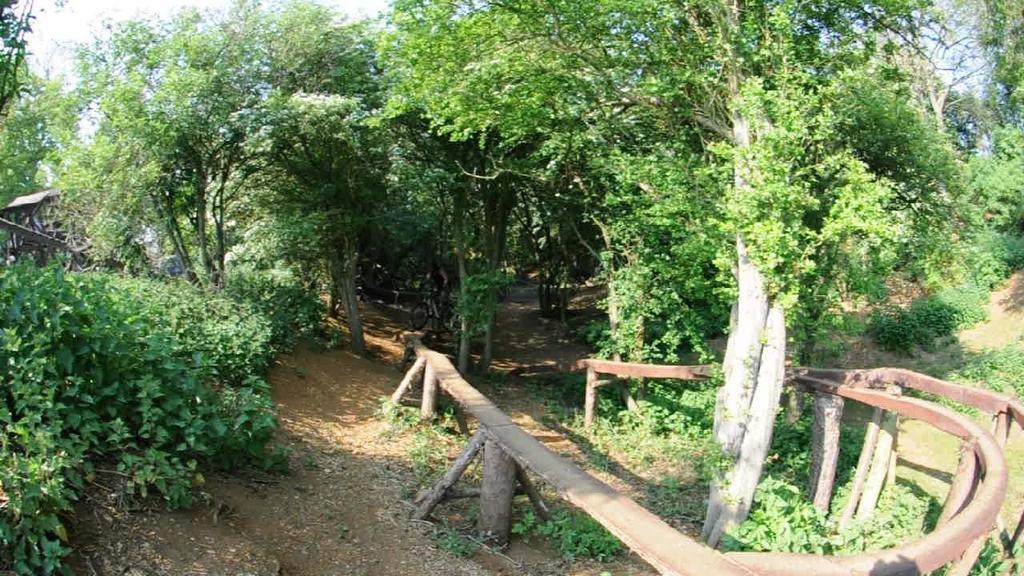How would you summarize this image in a sentence or two? We can see wooden fence, plants, trees and sky. 